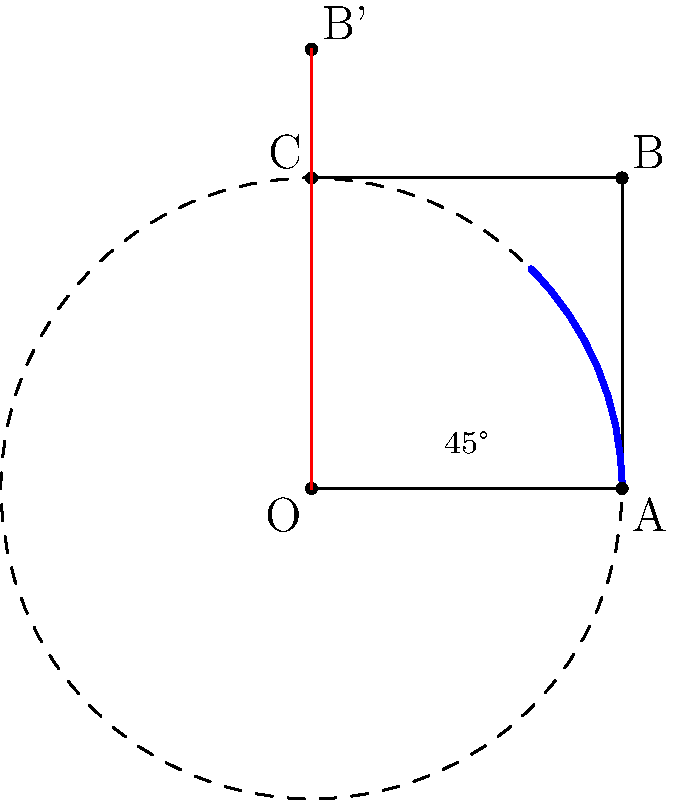A square OABC with side length 2 units is centered at the origin O. If the square is rotated 45° counterclockwise around O, what is the distance between point B and its new position B'? Express your answer in terms of $\sqrt{2}$. Let's approach this step-by-step:

1) First, we need to find the coordinates of point B before rotation:
   B = (2, 2)

2) The rotation doesn't change the distance from O to B, so OB = OB' = $\sqrt{2^2 + 2^2} = 2\sqrt{2}$

3) Now, we can think of B and B' as forming an isosceles triangle with O, where OB = OB' = $2\sqrt{2}$

4) The angle between OB and OB' is 45°, half of which is 22.5°

5) We can split this isosceles triangle into two right triangles. In one of these right triangles:
   - The hypotenuse is OB = $2\sqrt{2}$
   - One angle is 22.5°

6) The distance we're looking for (let's call it x) is twice the length of the leg opposite to the 22.5° angle in this right triangle

7) We can use the sine function to find half of x:
   $\sin(22.5°) = \frac{x/2}{2\sqrt{2}}$

8) Solving for x:
   $x = 4\sqrt{2} \sin(22.5°)$

9) $\sin(22.5°) = \frac{\sqrt{2}-1}{2}$

10) Substituting this in:
    $x = 4\sqrt{2} \cdot \frac{\sqrt{2}-1}{2} = 2(2-\sqrt{2})$

Therefore, the distance between B and B' is $2(2-\sqrt{2})$.
Answer: $2(2-\sqrt{2})$ 